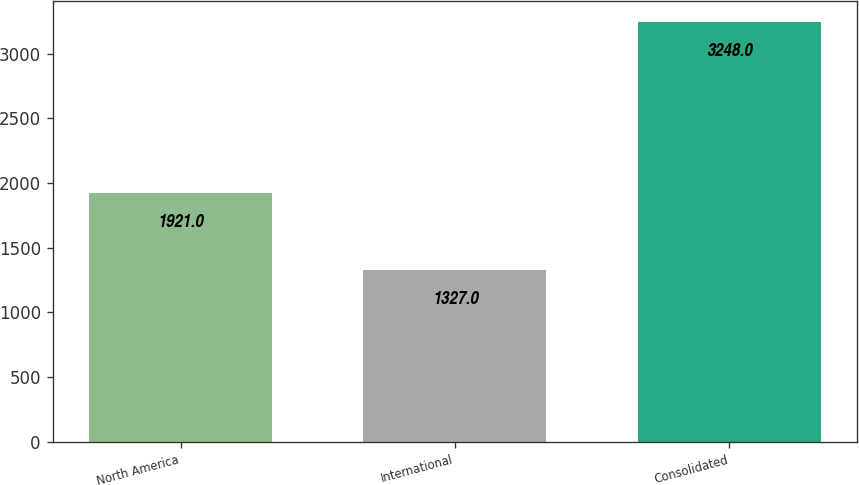Convert chart to OTSL. <chart><loc_0><loc_0><loc_500><loc_500><bar_chart><fcel>North America<fcel>International<fcel>Consolidated<nl><fcel>1921<fcel>1327<fcel>3248<nl></chart> 